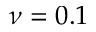<formula> <loc_0><loc_0><loc_500><loc_500>\nu = 0 . 1</formula> 